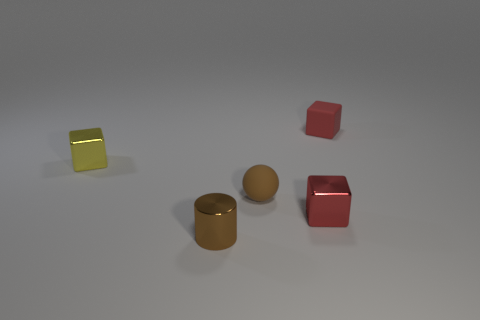There is a small cube that is made of the same material as the tiny brown sphere; what is its color?
Keep it short and to the point. Red. There is a metal thing that is the same color as the small rubber cube; what shape is it?
Your response must be concise. Cube. There is a object that is left of the metallic cylinder; is its size the same as the brown object that is behind the brown shiny thing?
Ensure brevity in your answer.  Yes. What number of cubes are either blue metallic things or tiny yellow shiny objects?
Provide a succinct answer. 1. Does the red cube right of the red shiny block have the same material as the tiny brown sphere?
Offer a terse response. Yes. What number of other objects are the same size as the brown rubber ball?
Provide a succinct answer. 4. What number of big objects are matte things or green blocks?
Your answer should be compact. 0. Is the shiny cylinder the same color as the small matte sphere?
Offer a very short reply. Yes. Is the number of brown balls on the left side of the tiny yellow metallic thing greater than the number of tiny matte objects that are right of the rubber block?
Make the answer very short. No. There is a tiny metallic cube right of the small yellow metal thing; does it have the same color as the rubber sphere?
Your answer should be very brief. No. 